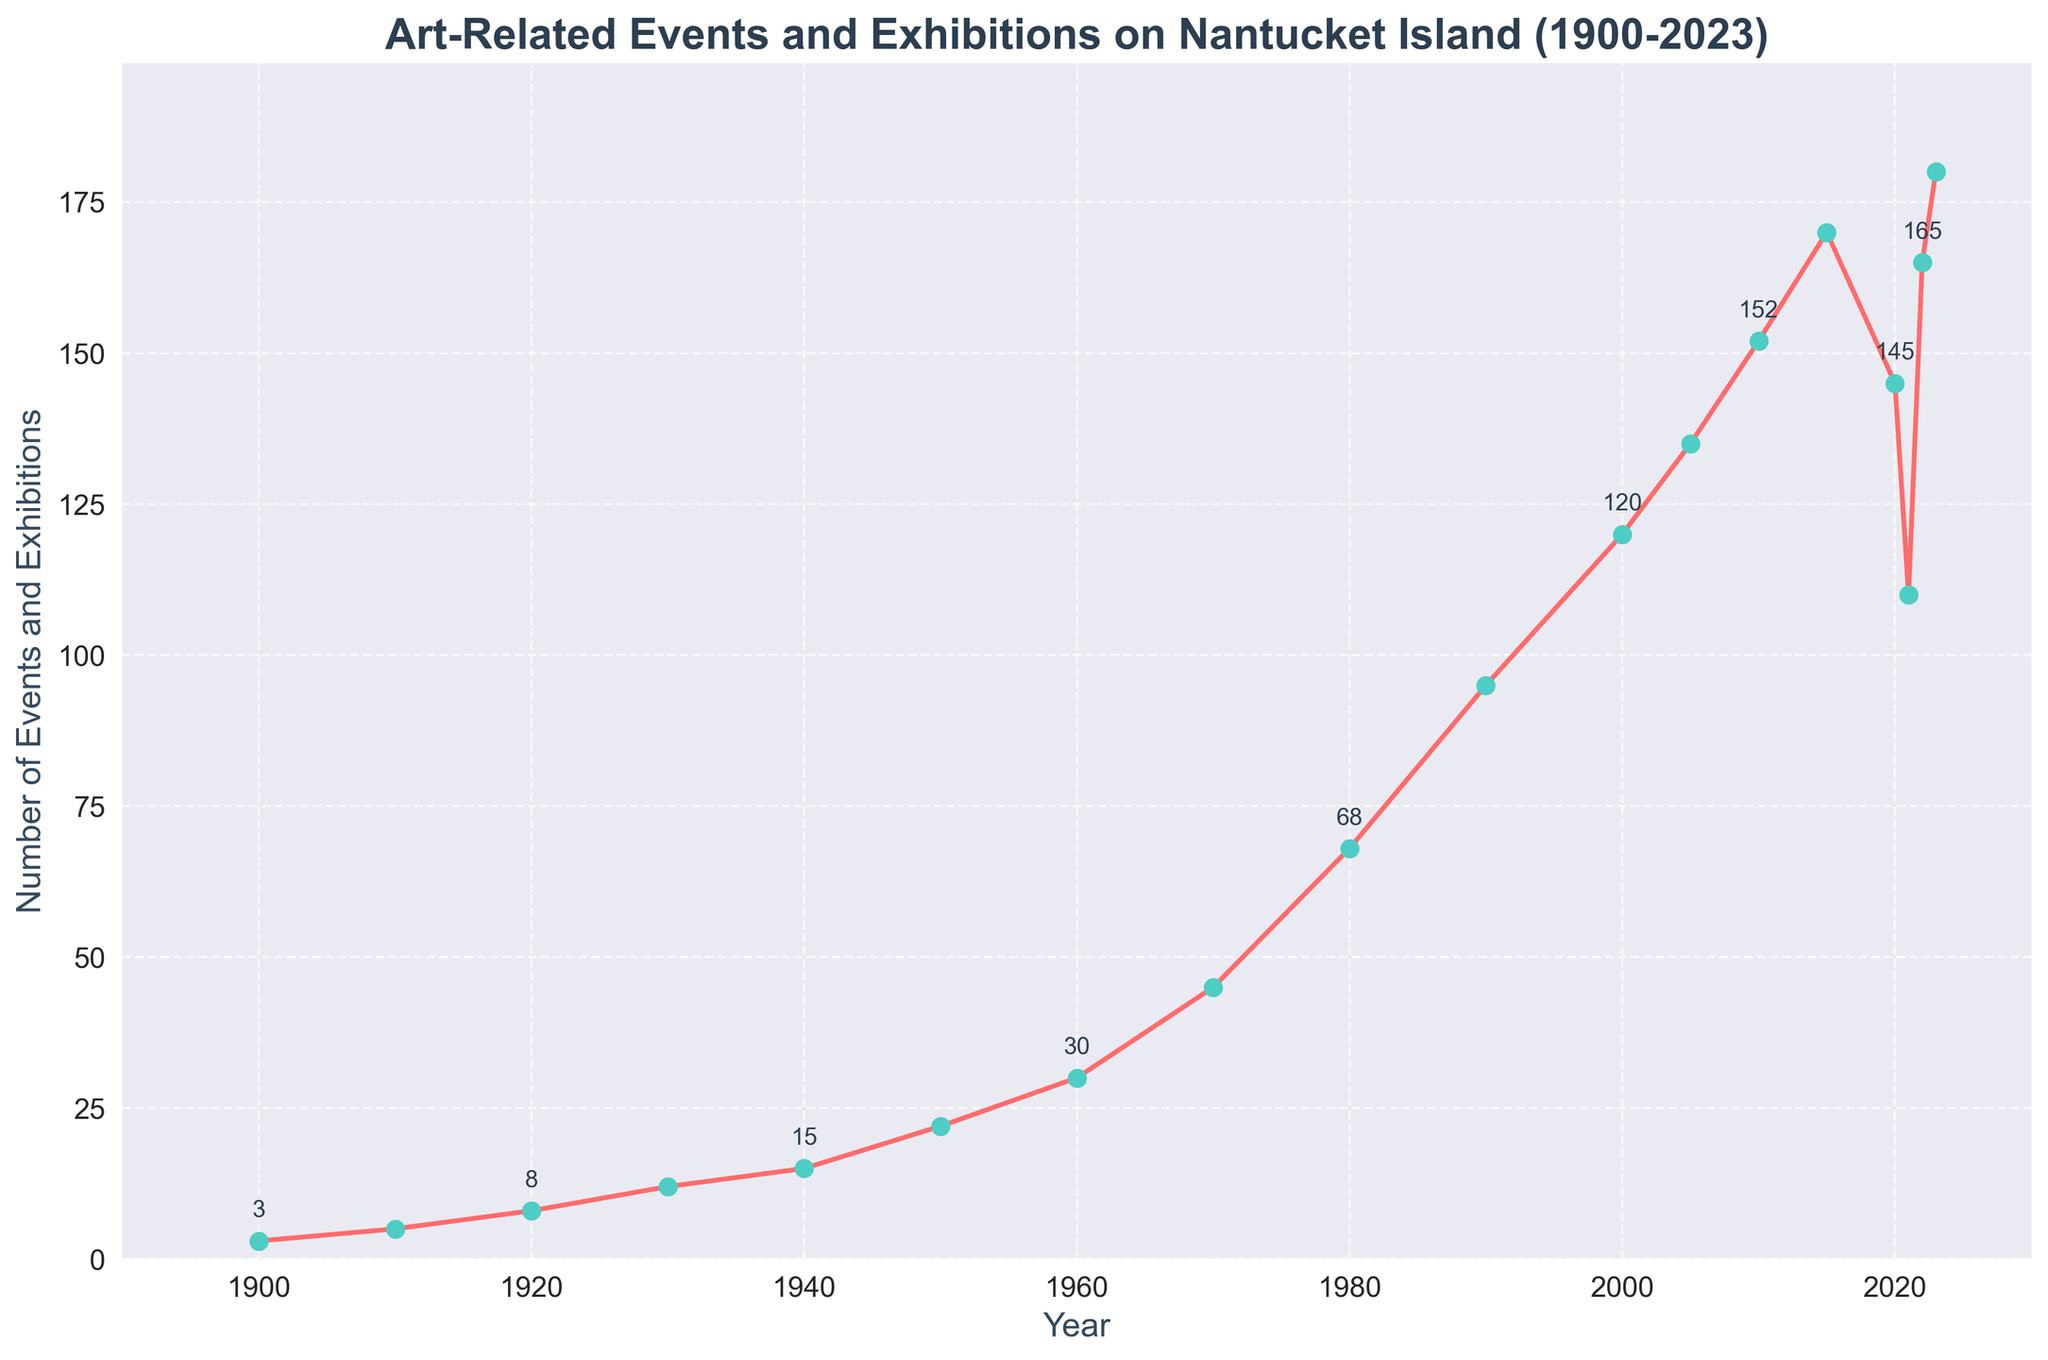What is the total increase in the number of art-related events and exhibitions from 1900 to 2023? In 1900, there were 3 events and in 2023, there were 180 events. The total increase can be calculated as 180 - 3 = 177
Answer: 177 Which decade saw the largest increase in the number of art-related events and exhibitions? By examining the figure, the decade from 1980 (68 events) to 1990 (95 events) shows an increase of 27 events, which is the largest among all decades
Answer: 1980-1990 How did the number of art-related events and exhibitions change between 2015 and 2021? In 2015, there were 170 events, and in 2021, there were 110 events. The change is 170 - 110 = 60, meaning there was a decrease of 60 events
Answer: Decrease by 60 What is the overall trend in the number of art-related events and exhibitions from 1900 to 2000? From 1900 (3 events) to 2000 (120 events), there is a consistent upward trend without drops
Answer: Upward trend During which periods did the number of art-related events and exhibitions experience a decline? The plot shows two significant declines: from 2015 (170 events) to 2020 (145 events), and from 2020 (145 events) to 2021 (110 events)
Answer: 2015-2020 and 2020-2021 Compare the number of events in 2000 and 2022. How much did the number increase or decrease? In 2000, there were 120 events, and in 2022, there were 165 events. The increase can be calculated as 165 - 120 = 45
Answer: Increase by 45 Which year marked the peak number of art-related events and exhibitions? From the figure, 2023 marks the peak with 180 events
Answer: 2023 What was the average number of events per year from 2000 to 2010 inclusive? Calculate the events in the years 2000, 2005, and 2010: (120 + 135 + 152) = 407. The average is 407/3 = 135.67
Answer: 135.67 What was the difference in the number of events between 1970 and 1980? In 1970, there were 45 events, and in 1980, there were 68 events. The difference is 68 - 45 = 23
Answer: 23 